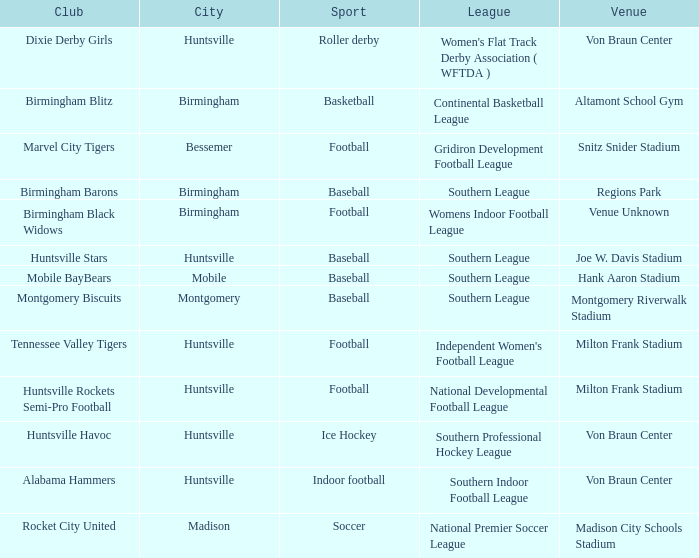What place hosted the gridiron development football league? Snitz Snider Stadium. 